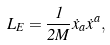<formula> <loc_0><loc_0><loc_500><loc_500>L _ { E } = \frac { 1 } { 2 M } { \dot { x } } _ { a } { \dot { x } } ^ { a } ,</formula> 